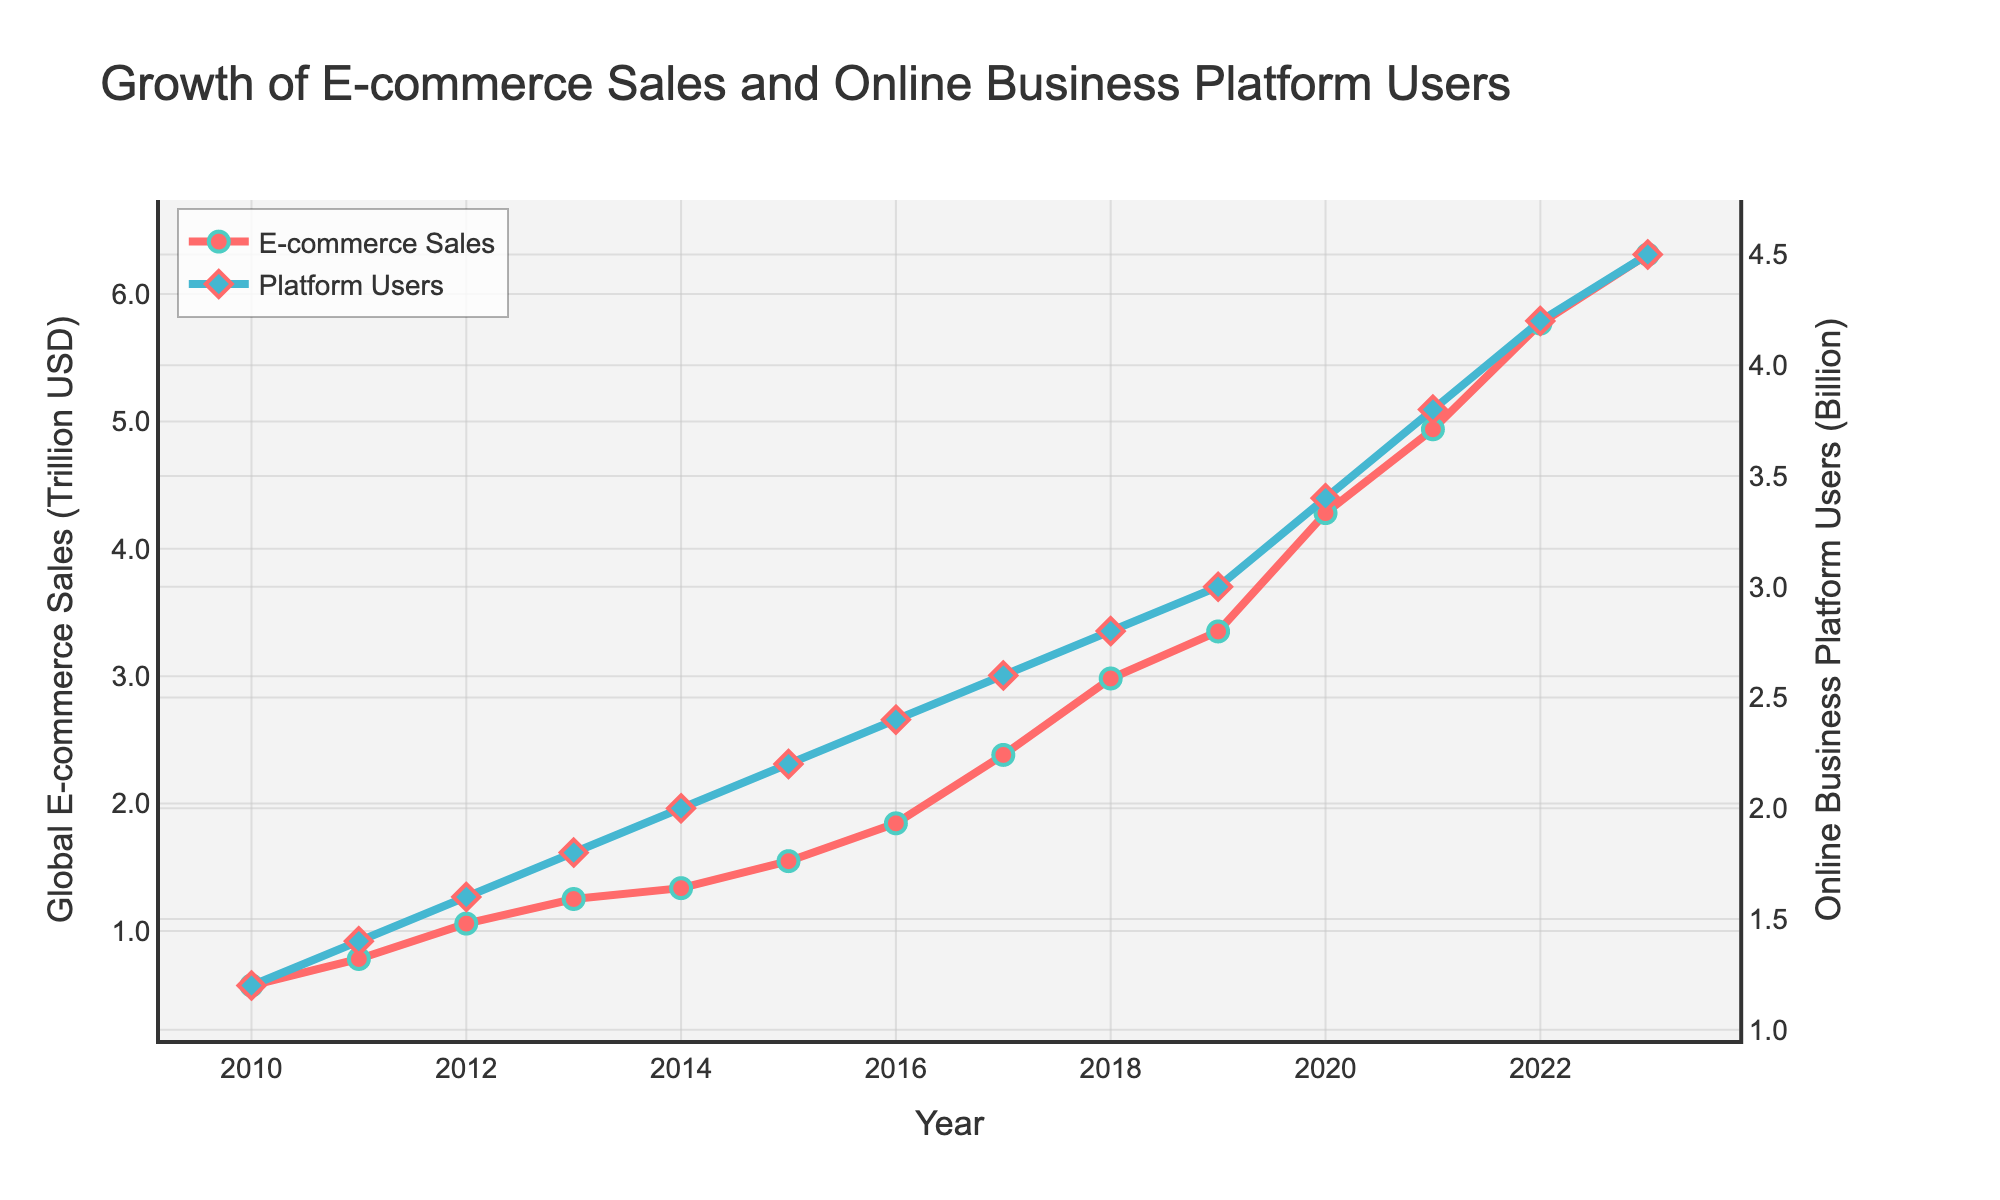How did the number of online business platform users change from 2010 to 2020? To find the change, subtract the 2010 value from the 2020 value: 3.4 billion users in 2020 minus 1.2 billion users in 2010 results in a change of (3.4 - 1.2) billion users.
Answer: 2.2 billion During which year(s) did global e-commerce sales surpass 4 trillion USD? Look at the line representing global e-commerce sales and find the years where the value exceeds 4 trillion USD. The value first surpasses 4 trillion USD in 2020.
Answer: 2020 By how much did the global e-commerce sales increase between 2018 and 2023? Calculate the difference between the values for 2018 and 2023: 6.310 trillion USD in 2023 minus 2.982 trillion USD in 2018 equals (6.310 - 2.982).
Answer: 3.328 trillion USD Which had a higher growth rate from 2015 to 2020, global e-commerce sales or online business platform users? Calculate the percentage growth for both. Sales: ((4.280 - 1.548) / 1.548) * 100 = 176.48%. Users: ((3.4 - 2.2) / 2.2) * 100 = 54.55%. E-commerce sales had a higher growth rate.
Answer: Global e-commerce sales Compare the growth trends of global e-commerce sales and online business platform users from 2010 to 2014. Observe the slopes of both lines from 2010 to 2014. Both show upward trends, with e-commerce sales rising from 0.572 to 1.336 trillion USD and platform users increasing from 1.2 to 2.0 billion. Both exhibit consistent growth, with sales growing slightly faster proportionally.
Answer: Both grew, with e-commerce sales faster In which year did both metrics (e-commerce sales and platform users) experience the most significant increases proportionally? Analyze year-on-year increases for both metrics. 2020 shows the most significant jumps: e-commerce sales grew from 3.351 trillion in 2019 to 4.280 trillion USD, while platform users increased from 3.0 billion to 3.4 billion.
Answer: 2020 What is the average annual increase in global e-commerce sales from 2010 to 2023? Calculate the total increase: 6.310 trillion in 2023 minus 0.572 trillion in 2010 equals 5.738 trillion. Divide by the number of years (2023 - 2010 = 13): 5.738 trillion / 13 ≈ 0.4428 trillion per year.
Answer: Approximately 0.4428 trillion USD per year How did the ratio of e-commerce sales to online business platform users change from 2012 to 2018? Calculate the ratio for both years: 2012's ratio = 1.058 trillion / 1.6 billion ≈ 0.6613. 2018's ratio = 2.982 trillion / 2.8 billion ≈ 1.065. The ratio increased from 2012 to 2018.
Answer: Increased Is the growth trend of online business platform users linear or exponential? Examine the line representing platform users. The consistent year-on-year increment and lack of drastic curve indicate a more linear growth rather than exponential.
Answer: Linear 